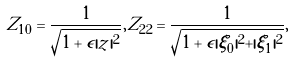<formula> <loc_0><loc_0><loc_500><loc_500>Z _ { 1 0 } = \frac { 1 } { \sqrt { 1 + \epsilon | z | ^ { 2 } } } , Z _ { 2 2 } = \frac { 1 } { \sqrt { 1 + \epsilon | \xi _ { 0 } | ^ { 2 } + | \xi _ { 1 } | ^ { 2 } } } ,</formula> 